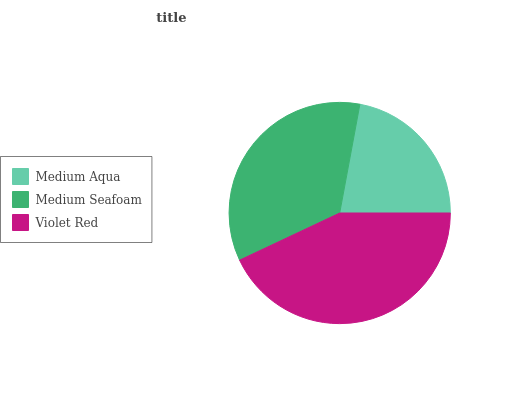Is Medium Aqua the minimum?
Answer yes or no. Yes. Is Violet Red the maximum?
Answer yes or no. Yes. Is Medium Seafoam the minimum?
Answer yes or no. No. Is Medium Seafoam the maximum?
Answer yes or no. No. Is Medium Seafoam greater than Medium Aqua?
Answer yes or no. Yes. Is Medium Aqua less than Medium Seafoam?
Answer yes or no. Yes. Is Medium Aqua greater than Medium Seafoam?
Answer yes or no. No. Is Medium Seafoam less than Medium Aqua?
Answer yes or no. No. Is Medium Seafoam the high median?
Answer yes or no. Yes. Is Medium Seafoam the low median?
Answer yes or no. Yes. Is Violet Red the high median?
Answer yes or no. No. Is Medium Aqua the low median?
Answer yes or no. No. 